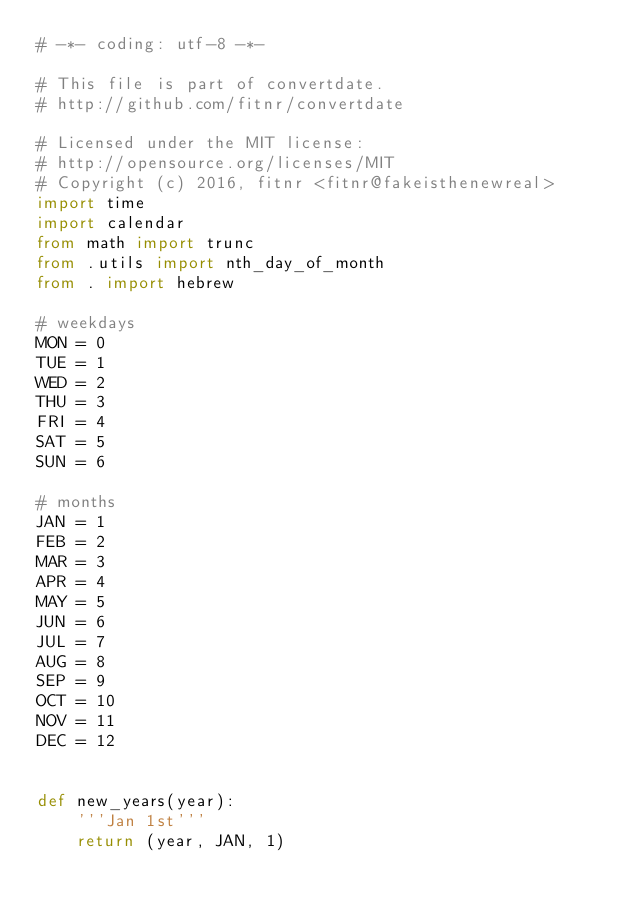Convert code to text. <code><loc_0><loc_0><loc_500><loc_500><_Python_># -*- coding: utf-8 -*-

# This file is part of convertdate.
# http://github.com/fitnr/convertdate

# Licensed under the MIT license:
# http://opensource.org/licenses/MIT
# Copyright (c) 2016, fitnr <fitnr@fakeisthenewreal>
import time
import calendar
from math import trunc
from .utils import nth_day_of_month
from . import hebrew

# weekdays
MON = 0
TUE = 1
WED = 2
THU = 3
FRI = 4
SAT = 5
SUN = 6

# months
JAN = 1
FEB = 2
MAR = 3
APR = 4
MAY = 5
JUN = 6
JUL = 7
AUG = 8
SEP = 9
OCT = 10
NOV = 11
DEC = 12


def new_years(year):
    '''Jan 1st'''
    return (year, JAN, 1)

</code> 